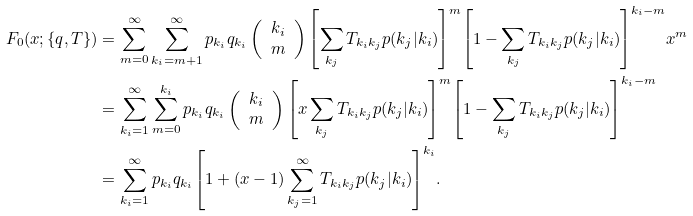Convert formula to latex. <formula><loc_0><loc_0><loc_500><loc_500>F _ { 0 } ( x ; \{ q , T \} ) & = \sum _ { m = 0 } ^ { \infty } \sum _ { k _ { i } = m + 1 } ^ { \infty } p _ { k _ { i } } q _ { k _ { i } } \left ( \begin{array} { c } k _ { i } \\ m \end{array} \right ) { \left [ \sum _ { k _ { j } } T _ { k _ { i } k _ { j } } p ( k _ { j } | k _ { i } ) \right ] } ^ { m } { \left [ 1 - \sum _ { k _ { j } } T _ { k _ { i } k _ { j } } p ( k _ { j } | k _ { i } ) \right ] } ^ { k _ { i } - m } x ^ { m } \\ & = \sum _ { k _ { i } = 1 } ^ { \infty } \sum _ { m = 0 } ^ { k _ { i } } p _ { k _ { i } } q _ { k _ { i } } \left ( \begin{array} { c } k _ { i } \\ m \end{array} \right ) { \left [ x \sum _ { k _ { j } } T _ { k _ { i } k _ { j } } p ( k _ { j } | k _ { i } ) \right ] } ^ { m } { \left [ 1 - \sum _ { k _ { j } } T _ { k _ { i } k _ { j } } p ( k _ { j } | k _ { i } ) \right ] } ^ { k _ { i } - m } \\ & = \sum _ { k _ { i } = 1 } ^ { \infty } p _ { k _ { i } } q _ { k _ { i } } { \left [ 1 + ( x - 1 ) \sum _ { k _ { j } = 1 } ^ { \infty } T _ { k _ { i } k _ { j } } p ( k _ { j } | k _ { i } ) \right ] } ^ { k _ { i } } .</formula> 